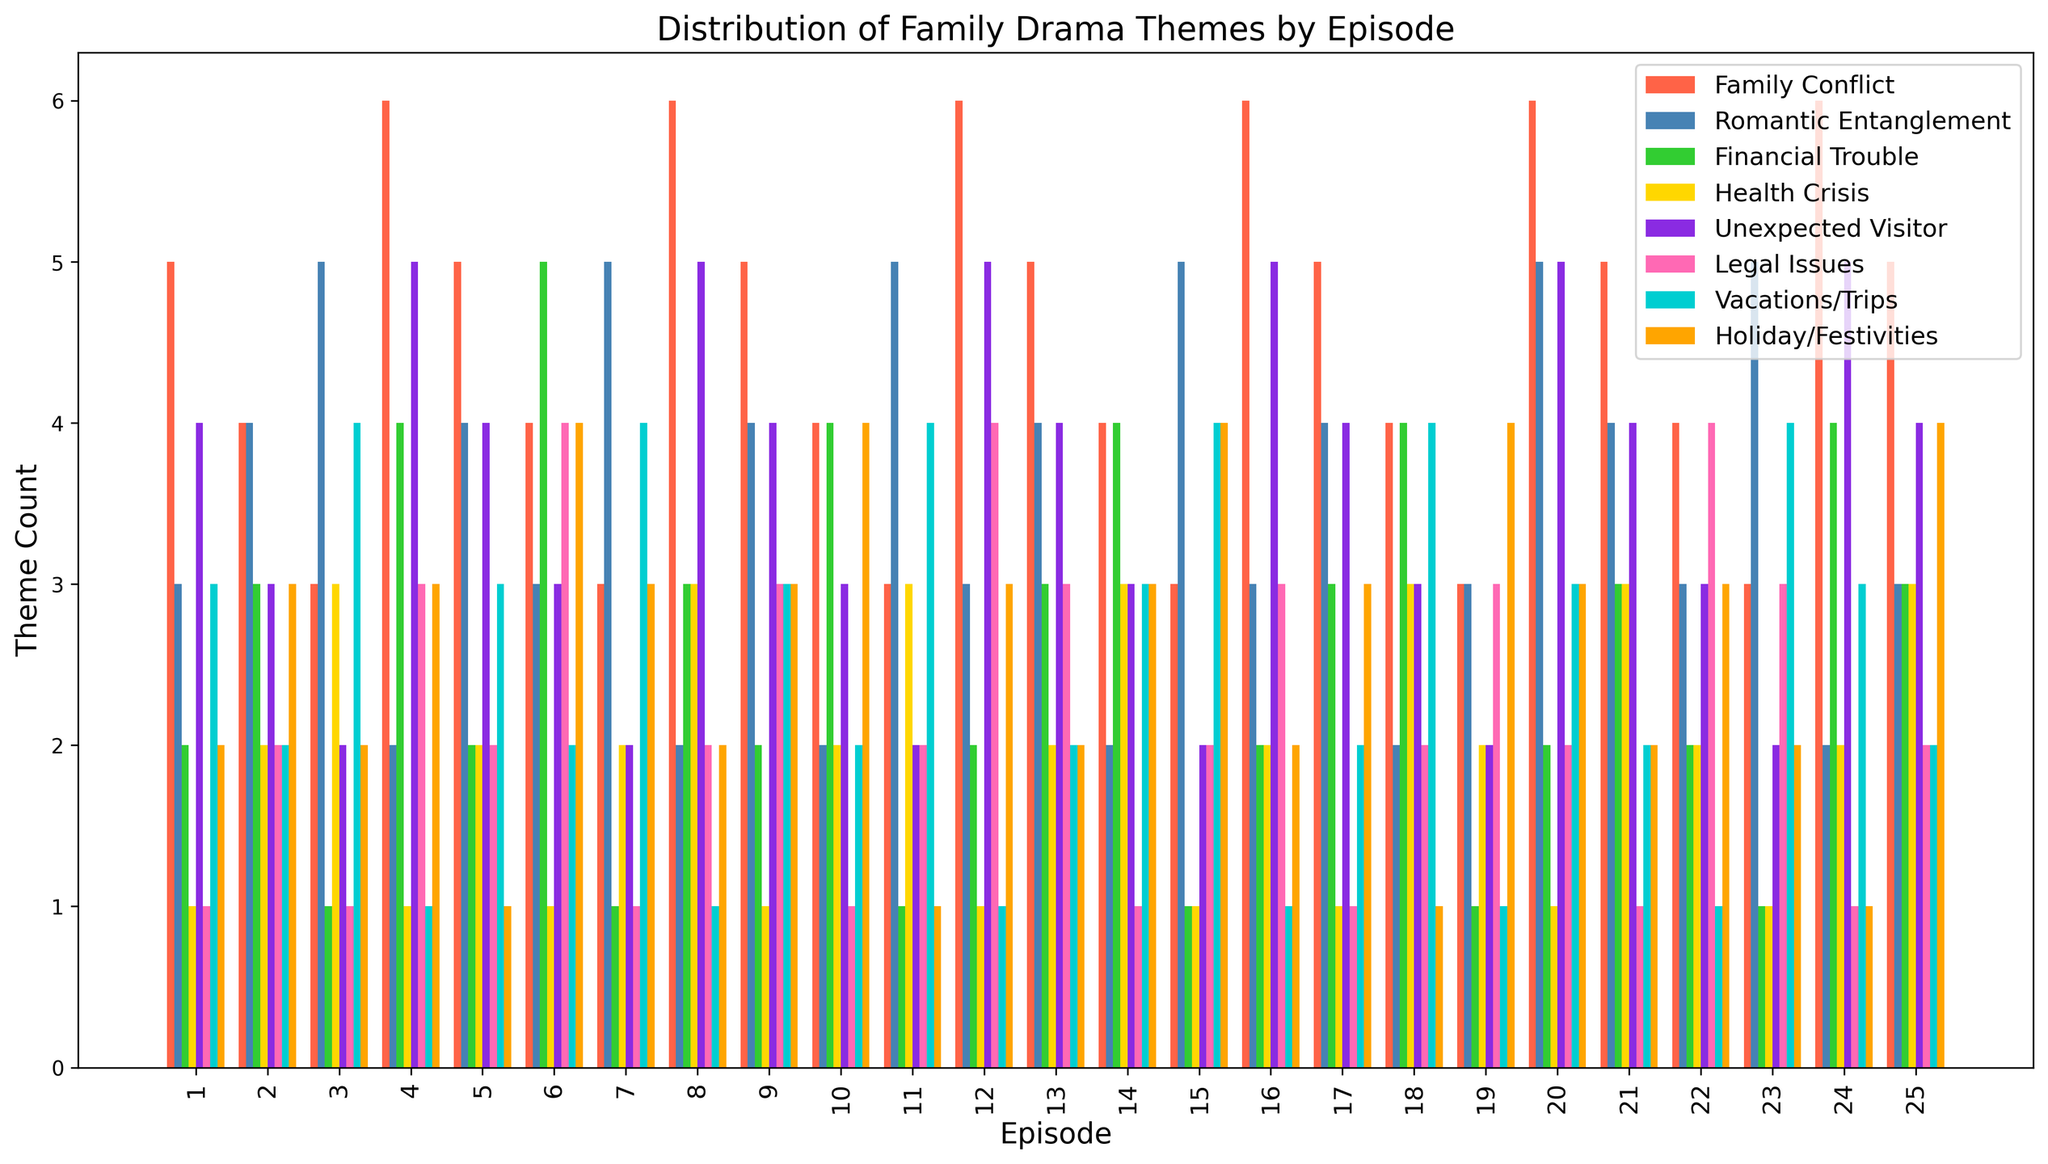What type of family drama theme appears most frequently in Episode 8? Look at the bars for Episode 8 and find the one with the greatest height. The 'Unexpected Visitor' theme appears most frequently with a count of 5.
Answer: Unexpected Visitor How many more instances of 'Family Conflict' are there compared to 'Health Crisis' in Episode 4? In Episode 4, 'Family Conflict' has a count of 6, and 'Health Crisis' has a count of 1. The difference is 6 - 1 = 5.
Answer: 5 Between Episodes 3 and 7, which episode had more 'Romantic Entanglement' occurrences and by how much? Compare the heights of the 'Romantic Entanglement' bars for Episodes 3 and 7. Episode 3 has a count of 5, and Episode 7 has a count of 5. The difference is 5 - 5 = 0.
Answer: 0 Which theme consistently appears in all episodes and is shown by blue bars? Identify the theme associated with blue bars and check if there is a bar in every episode. The 'Romantic Entanglement' theme, represented by blue bars, appears in every episode.
Answer: Romantic Entanglement What is the average count of 'Vacations/Trips' across all episodes? Sum the counts of 'Vacations/Trips' across all episodes and then divide by the number of episodes. The total count is (3+2+4+1+3+2+4+1+3+2+4+1+2+3+4+1+2+4+1+3+2+1+4+3+2) = 63. The average is 63/25 = 2.52
Answer: 2.52 In which episode(s) does 'Financial Trouble' have the highest count? Find the tallest 'Financial Trouble' bar across all episodes. The highest count for 'Financial Trouble' is 5, appearing in Episodes 6.
Answer: Episode 6 What is the total count of 'Holiday/Festivities' themes in episodes 10 and 15? Sum the counts for 'Holiday/Festivities' in Episodes 10 and 15. The counts are 4 and 4, respectively. The total is 4+4=8.
Answer: 8 Is there an episode where both 'Legal Issues' and 'Health Crisis' have counts greater than 3? Check each episode where both 'Legal Issues' and 'Health Crisis' have counts greater than 3. Episode 6 has 'Legal Issues' count of 4 and 'Health Crisis' count of 5.
Answer: Yes Comparing Episodes 1 and 25, which episode had a higher total count of drama themes? Sum the counts of all drama themes for Episodes 1 and 25. Episode 1 total: 21. Episode 25 total: 26.
Answer: Episode 25 Which family drama theme has the lowest total count across all episodes? Sum the counts of each theme across all episodes and find the theme with the minimum total. 'Health Crisis' total is the lowest with 41 instances.
Answer: Health Crisis 